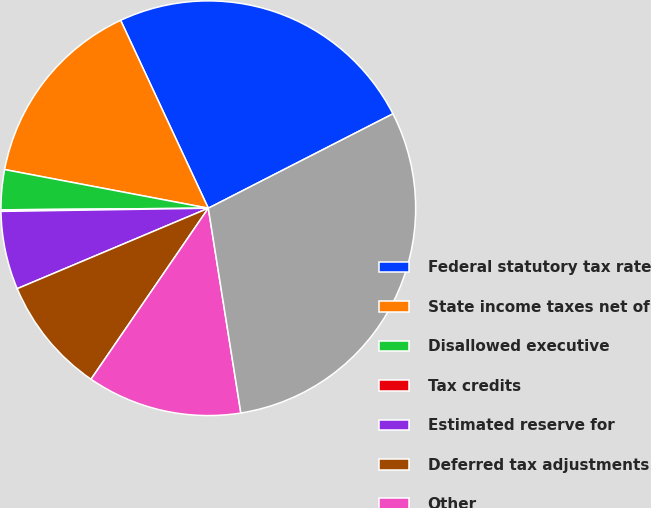Convert chart to OTSL. <chart><loc_0><loc_0><loc_500><loc_500><pie_chart><fcel>Federal statutory tax rate<fcel>State income taxes net of<fcel>Disallowed executive<fcel>Tax credits<fcel>Estimated reserve for<fcel>Deferred tax adjustments<fcel>Other<fcel>Effective tax rate<nl><fcel>24.43%<fcel>15.07%<fcel>3.11%<fcel>0.12%<fcel>6.1%<fcel>9.09%<fcel>12.08%<fcel>30.02%<nl></chart> 